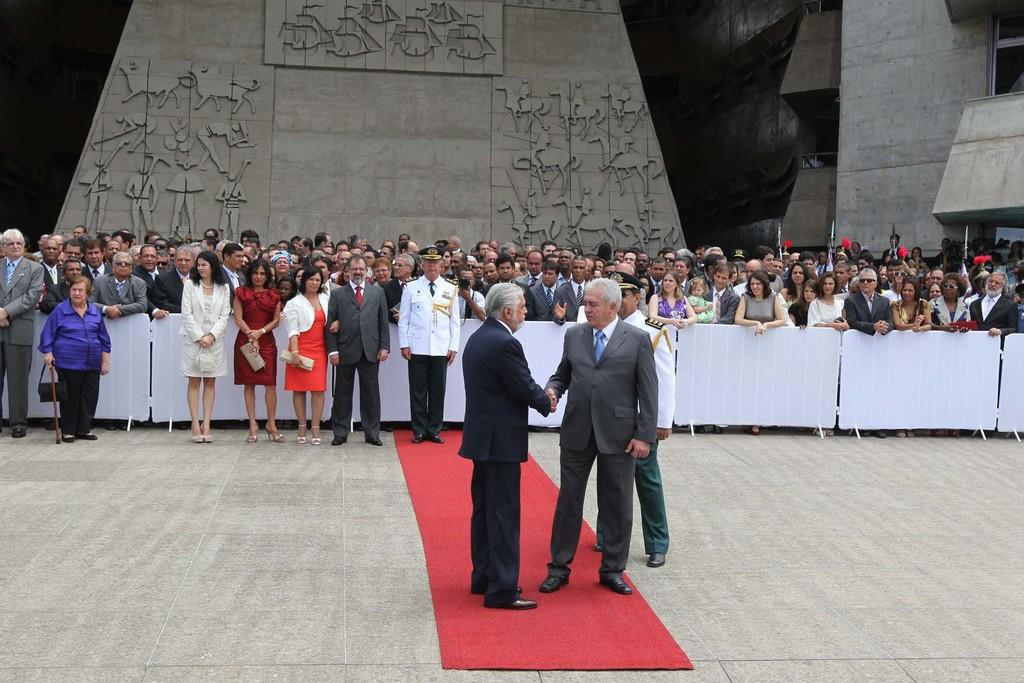What are the two men in the middle of the image doing? The two men in the middle of the image are standing and shaking hands. What are the men wearing in the image? The men are wearing coats in the image. Are there any other people present in the middle of the image? Yes, there are other people standing in the middle of the image. How many ladybugs can be seen on the coats of the men in the image? There are no ladybugs visible on the coats of the men in the image. What type of arch is present in the background of the image? There is no arch present in the background of the image. 